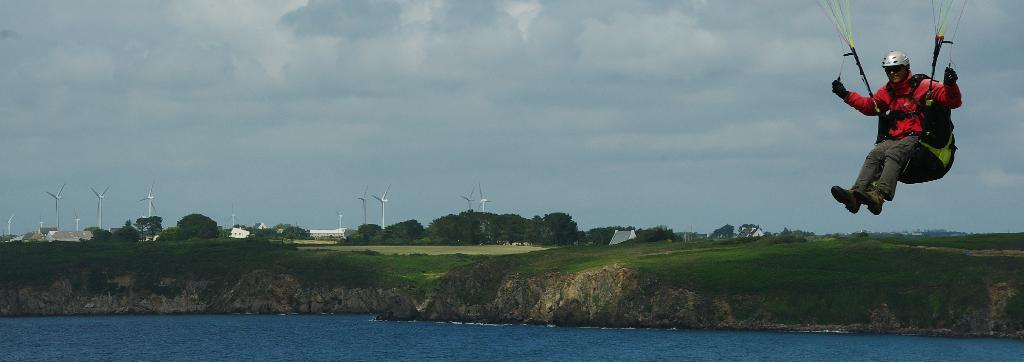What is the main subject in the center of the image? There is a man flying in the center of the image. What can be seen in the background of the image? There is water, grass, trees, wind vanes, a building, and the sky visible in the background of the image. What type of weather is suggested by the clouds in the sky? The presence of clouds in the sky suggests that the weather might be partly cloudy. What scientific experiment is the man conducting in the image? There is no indication in the man is conducting a scientific experiment in the image; he is simply flying. Can you tell me where the sister of the man is located in the image? There is no mention of a sister in the image or the provided facts, so it is not possible to determine her location. 